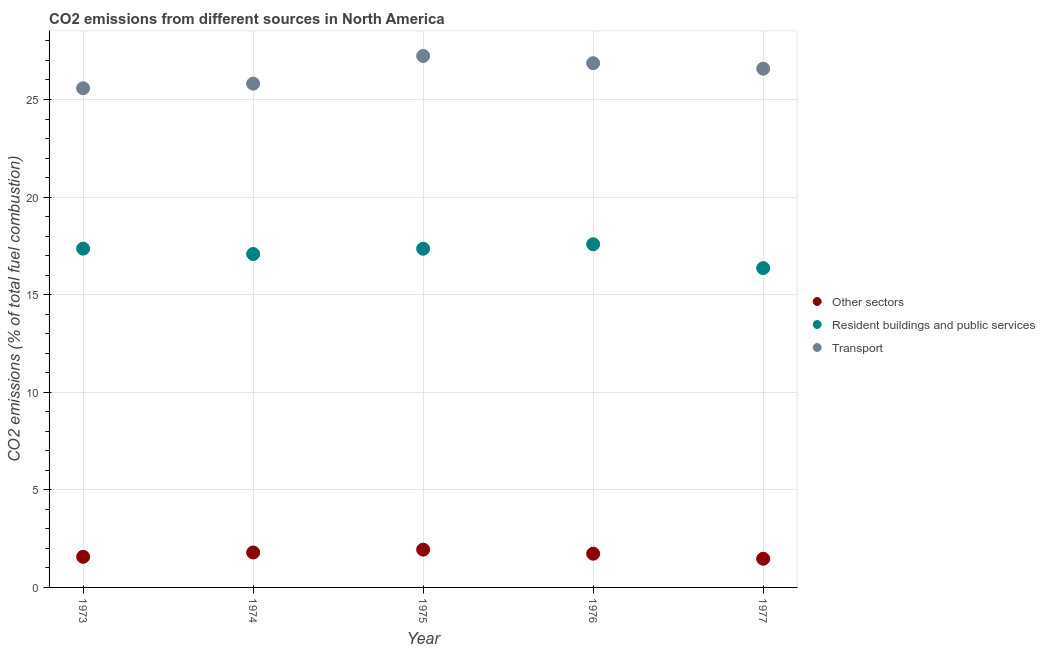How many different coloured dotlines are there?
Give a very brief answer. 3. What is the percentage of co2 emissions from resident buildings and public services in 1974?
Keep it short and to the point. 17.08. Across all years, what is the maximum percentage of co2 emissions from other sectors?
Keep it short and to the point. 1.94. Across all years, what is the minimum percentage of co2 emissions from other sectors?
Provide a short and direct response. 1.47. In which year was the percentage of co2 emissions from other sectors maximum?
Keep it short and to the point. 1975. What is the total percentage of co2 emissions from resident buildings and public services in the graph?
Offer a terse response. 85.74. What is the difference between the percentage of co2 emissions from resident buildings and public services in 1973 and that in 1975?
Keep it short and to the point. 0.01. What is the difference between the percentage of co2 emissions from resident buildings and public services in 1977 and the percentage of co2 emissions from other sectors in 1973?
Ensure brevity in your answer.  14.79. What is the average percentage of co2 emissions from other sectors per year?
Provide a short and direct response. 1.7. In the year 1976, what is the difference between the percentage of co2 emissions from other sectors and percentage of co2 emissions from resident buildings and public services?
Make the answer very short. -15.86. In how many years, is the percentage of co2 emissions from other sectors greater than 21 %?
Ensure brevity in your answer.  0. What is the ratio of the percentage of co2 emissions from transport in 1973 to that in 1975?
Keep it short and to the point. 0.94. Is the difference between the percentage of co2 emissions from resident buildings and public services in 1975 and 1976 greater than the difference between the percentage of co2 emissions from other sectors in 1975 and 1976?
Offer a very short reply. No. What is the difference between the highest and the second highest percentage of co2 emissions from resident buildings and public services?
Offer a very short reply. 0.22. What is the difference between the highest and the lowest percentage of co2 emissions from resident buildings and public services?
Ensure brevity in your answer.  1.22. In how many years, is the percentage of co2 emissions from transport greater than the average percentage of co2 emissions from transport taken over all years?
Offer a very short reply. 3. Is it the case that in every year, the sum of the percentage of co2 emissions from other sectors and percentage of co2 emissions from resident buildings and public services is greater than the percentage of co2 emissions from transport?
Your response must be concise. No. Does the percentage of co2 emissions from resident buildings and public services monotonically increase over the years?
Your response must be concise. No. Is the percentage of co2 emissions from other sectors strictly greater than the percentage of co2 emissions from transport over the years?
Give a very brief answer. No. How many years are there in the graph?
Ensure brevity in your answer.  5. What is the difference between two consecutive major ticks on the Y-axis?
Your answer should be compact. 5. Where does the legend appear in the graph?
Provide a succinct answer. Center right. How many legend labels are there?
Offer a very short reply. 3. What is the title of the graph?
Make the answer very short. CO2 emissions from different sources in North America. Does "Ireland" appear as one of the legend labels in the graph?
Make the answer very short. No. What is the label or title of the X-axis?
Provide a succinct answer. Year. What is the label or title of the Y-axis?
Provide a succinct answer. CO2 emissions (% of total fuel combustion). What is the CO2 emissions (% of total fuel combustion) of Other sectors in 1973?
Offer a terse response. 1.57. What is the CO2 emissions (% of total fuel combustion) in Resident buildings and public services in 1973?
Your response must be concise. 17.36. What is the CO2 emissions (% of total fuel combustion) in Transport in 1973?
Provide a succinct answer. 25.58. What is the CO2 emissions (% of total fuel combustion) of Other sectors in 1974?
Your response must be concise. 1.79. What is the CO2 emissions (% of total fuel combustion) in Resident buildings and public services in 1974?
Make the answer very short. 17.08. What is the CO2 emissions (% of total fuel combustion) in Transport in 1974?
Make the answer very short. 25.81. What is the CO2 emissions (% of total fuel combustion) of Other sectors in 1975?
Offer a terse response. 1.94. What is the CO2 emissions (% of total fuel combustion) of Resident buildings and public services in 1975?
Provide a succinct answer. 17.35. What is the CO2 emissions (% of total fuel combustion) in Transport in 1975?
Ensure brevity in your answer.  27.23. What is the CO2 emissions (% of total fuel combustion) of Other sectors in 1976?
Make the answer very short. 1.73. What is the CO2 emissions (% of total fuel combustion) in Resident buildings and public services in 1976?
Provide a short and direct response. 17.58. What is the CO2 emissions (% of total fuel combustion) of Transport in 1976?
Give a very brief answer. 26.86. What is the CO2 emissions (% of total fuel combustion) in Other sectors in 1977?
Your answer should be very brief. 1.47. What is the CO2 emissions (% of total fuel combustion) in Resident buildings and public services in 1977?
Keep it short and to the point. 16.36. What is the CO2 emissions (% of total fuel combustion) in Transport in 1977?
Your answer should be very brief. 26.58. Across all years, what is the maximum CO2 emissions (% of total fuel combustion) of Other sectors?
Give a very brief answer. 1.94. Across all years, what is the maximum CO2 emissions (% of total fuel combustion) in Resident buildings and public services?
Ensure brevity in your answer.  17.58. Across all years, what is the maximum CO2 emissions (% of total fuel combustion) in Transport?
Keep it short and to the point. 27.23. Across all years, what is the minimum CO2 emissions (% of total fuel combustion) in Other sectors?
Your answer should be compact. 1.47. Across all years, what is the minimum CO2 emissions (% of total fuel combustion) of Resident buildings and public services?
Offer a terse response. 16.36. Across all years, what is the minimum CO2 emissions (% of total fuel combustion) of Transport?
Make the answer very short. 25.58. What is the total CO2 emissions (% of total fuel combustion) in Other sectors in the graph?
Offer a very short reply. 8.49. What is the total CO2 emissions (% of total fuel combustion) in Resident buildings and public services in the graph?
Provide a succinct answer. 85.74. What is the total CO2 emissions (% of total fuel combustion) of Transport in the graph?
Your answer should be compact. 132.06. What is the difference between the CO2 emissions (% of total fuel combustion) in Other sectors in 1973 and that in 1974?
Offer a very short reply. -0.22. What is the difference between the CO2 emissions (% of total fuel combustion) in Resident buildings and public services in 1973 and that in 1974?
Offer a terse response. 0.28. What is the difference between the CO2 emissions (% of total fuel combustion) of Transport in 1973 and that in 1974?
Offer a very short reply. -0.24. What is the difference between the CO2 emissions (% of total fuel combustion) of Other sectors in 1973 and that in 1975?
Provide a succinct answer. -0.37. What is the difference between the CO2 emissions (% of total fuel combustion) in Resident buildings and public services in 1973 and that in 1975?
Make the answer very short. 0.01. What is the difference between the CO2 emissions (% of total fuel combustion) of Transport in 1973 and that in 1975?
Give a very brief answer. -1.66. What is the difference between the CO2 emissions (% of total fuel combustion) of Other sectors in 1973 and that in 1976?
Make the answer very short. -0.16. What is the difference between the CO2 emissions (% of total fuel combustion) in Resident buildings and public services in 1973 and that in 1976?
Your answer should be compact. -0.22. What is the difference between the CO2 emissions (% of total fuel combustion) in Transport in 1973 and that in 1976?
Offer a very short reply. -1.29. What is the difference between the CO2 emissions (% of total fuel combustion) of Other sectors in 1973 and that in 1977?
Provide a succinct answer. 0.1. What is the difference between the CO2 emissions (% of total fuel combustion) of Resident buildings and public services in 1973 and that in 1977?
Your answer should be compact. 1. What is the difference between the CO2 emissions (% of total fuel combustion) of Transport in 1973 and that in 1977?
Ensure brevity in your answer.  -1. What is the difference between the CO2 emissions (% of total fuel combustion) of Other sectors in 1974 and that in 1975?
Ensure brevity in your answer.  -0.15. What is the difference between the CO2 emissions (% of total fuel combustion) of Resident buildings and public services in 1974 and that in 1975?
Keep it short and to the point. -0.27. What is the difference between the CO2 emissions (% of total fuel combustion) in Transport in 1974 and that in 1975?
Your answer should be compact. -1.42. What is the difference between the CO2 emissions (% of total fuel combustion) in Other sectors in 1974 and that in 1976?
Provide a short and direct response. 0.06. What is the difference between the CO2 emissions (% of total fuel combustion) in Resident buildings and public services in 1974 and that in 1976?
Provide a succinct answer. -0.5. What is the difference between the CO2 emissions (% of total fuel combustion) in Transport in 1974 and that in 1976?
Offer a very short reply. -1.05. What is the difference between the CO2 emissions (% of total fuel combustion) of Other sectors in 1974 and that in 1977?
Your answer should be compact. 0.32. What is the difference between the CO2 emissions (% of total fuel combustion) of Resident buildings and public services in 1974 and that in 1977?
Offer a very short reply. 0.72. What is the difference between the CO2 emissions (% of total fuel combustion) in Transport in 1974 and that in 1977?
Offer a terse response. -0.77. What is the difference between the CO2 emissions (% of total fuel combustion) in Other sectors in 1975 and that in 1976?
Make the answer very short. 0.21. What is the difference between the CO2 emissions (% of total fuel combustion) in Resident buildings and public services in 1975 and that in 1976?
Provide a succinct answer. -0.23. What is the difference between the CO2 emissions (% of total fuel combustion) in Transport in 1975 and that in 1976?
Keep it short and to the point. 0.37. What is the difference between the CO2 emissions (% of total fuel combustion) of Other sectors in 1975 and that in 1977?
Ensure brevity in your answer.  0.47. What is the difference between the CO2 emissions (% of total fuel combustion) of Transport in 1975 and that in 1977?
Make the answer very short. 0.65. What is the difference between the CO2 emissions (% of total fuel combustion) of Other sectors in 1976 and that in 1977?
Make the answer very short. 0.26. What is the difference between the CO2 emissions (% of total fuel combustion) in Resident buildings and public services in 1976 and that in 1977?
Provide a succinct answer. 1.22. What is the difference between the CO2 emissions (% of total fuel combustion) in Transport in 1976 and that in 1977?
Your answer should be very brief. 0.28. What is the difference between the CO2 emissions (% of total fuel combustion) of Other sectors in 1973 and the CO2 emissions (% of total fuel combustion) of Resident buildings and public services in 1974?
Give a very brief answer. -15.51. What is the difference between the CO2 emissions (% of total fuel combustion) in Other sectors in 1973 and the CO2 emissions (% of total fuel combustion) in Transport in 1974?
Provide a succinct answer. -24.24. What is the difference between the CO2 emissions (% of total fuel combustion) of Resident buildings and public services in 1973 and the CO2 emissions (% of total fuel combustion) of Transport in 1974?
Your answer should be compact. -8.45. What is the difference between the CO2 emissions (% of total fuel combustion) in Other sectors in 1973 and the CO2 emissions (% of total fuel combustion) in Resident buildings and public services in 1975?
Ensure brevity in your answer.  -15.78. What is the difference between the CO2 emissions (% of total fuel combustion) of Other sectors in 1973 and the CO2 emissions (% of total fuel combustion) of Transport in 1975?
Give a very brief answer. -25.66. What is the difference between the CO2 emissions (% of total fuel combustion) of Resident buildings and public services in 1973 and the CO2 emissions (% of total fuel combustion) of Transport in 1975?
Your answer should be compact. -9.87. What is the difference between the CO2 emissions (% of total fuel combustion) of Other sectors in 1973 and the CO2 emissions (% of total fuel combustion) of Resident buildings and public services in 1976?
Your answer should be very brief. -16.01. What is the difference between the CO2 emissions (% of total fuel combustion) in Other sectors in 1973 and the CO2 emissions (% of total fuel combustion) in Transport in 1976?
Give a very brief answer. -25.29. What is the difference between the CO2 emissions (% of total fuel combustion) of Resident buildings and public services in 1973 and the CO2 emissions (% of total fuel combustion) of Transport in 1976?
Provide a succinct answer. -9.5. What is the difference between the CO2 emissions (% of total fuel combustion) of Other sectors in 1973 and the CO2 emissions (% of total fuel combustion) of Resident buildings and public services in 1977?
Ensure brevity in your answer.  -14.79. What is the difference between the CO2 emissions (% of total fuel combustion) in Other sectors in 1973 and the CO2 emissions (% of total fuel combustion) in Transport in 1977?
Give a very brief answer. -25.01. What is the difference between the CO2 emissions (% of total fuel combustion) in Resident buildings and public services in 1973 and the CO2 emissions (% of total fuel combustion) in Transport in 1977?
Provide a short and direct response. -9.22. What is the difference between the CO2 emissions (% of total fuel combustion) of Other sectors in 1974 and the CO2 emissions (% of total fuel combustion) of Resident buildings and public services in 1975?
Your answer should be very brief. -15.56. What is the difference between the CO2 emissions (% of total fuel combustion) of Other sectors in 1974 and the CO2 emissions (% of total fuel combustion) of Transport in 1975?
Your response must be concise. -25.44. What is the difference between the CO2 emissions (% of total fuel combustion) of Resident buildings and public services in 1974 and the CO2 emissions (% of total fuel combustion) of Transport in 1975?
Your answer should be very brief. -10.15. What is the difference between the CO2 emissions (% of total fuel combustion) in Other sectors in 1974 and the CO2 emissions (% of total fuel combustion) in Resident buildings and public services in 1976?
Keep it short and to the point. -15.79. What is the difference between the CO2 emissions (% of total fuel combustion) in Other sectors in 1974 and the CO2 emissions (% of total fuel combustion) in Transport in 1976?
Give a very brief answer. -25.07. What is the difference between the CO2 emissions (% of total fuel combustion) of Resident buildings and public services in 1974 and the CO2 emissions (% of total fuel combustion) of Transport in 1976?
Your answer should be compact. -9.78. What is the difference between the CO2 emissions (% of total fuel combustion) of Other sectors in 1974 and the CO2 emissions (% of total fuel combustion) of Resident buildings and public services in 1977?
Ensure brevity in your answer.  -14.57. What is the difference between the CO2 emissions (% of total fuel combustion) of Other sectors in 1974 and the CO2 emissions (% of total fuel combustion) of Transport in 1977?
Make the answer very short. -24.79. What is the difference between the CO2 emissions (% of total fuel combustion) of Resident buildings and public services in 1974 and the CO2 emissions (% of total fuel combustion) of Transport in 1977?
Your answer should be compact. -9.5. What is the difference between the CO2 emissions (% of total fuel combustion) of Other sectors in 1975 and the CO2 emissions (% of total fuel combustion) of Resident buildings and public services in 1976?
Your answer should be very brief. -15.65. What is the difference between the CO2 emissions (% of total fuel combustion) in Other sectors in 1975 and the CO2 emissions (% of total fuel combustion) in Transport in 1976?
Your response must be concise. -24.93. What is the difference between the CO2 emissions (% of total fuel combustion) in Resident buildings and public services in 1975 and the CO2 emissions (% of total fuel combustion) in Transport in 1976?
Your answer should be compact. -9.51. What is the difference between the CO2 emissions (% of total fuel combustion) in Other sectors in 1975 and the CO2 emissions (% of total fuel combustion) in Resident buildings and public services in 1977?
Make the answer very short. -14.42. What is the difference between the CO2 emissions (% of total fuel combustion) of Other sectors in 1975 and the CO2 emissions (% of total fuel combustion) of Transport in 1977?
Your answer should be very brief. -24.64. What is the difference between the CO2 emissions (% of total fuel combustion) in Resident buildings and public services in 1975 and the CO2 emissions (% of total fuel combustion) in Transport in 1977?
Your answer should be compact. -9.23. What is the difference between the CO2 emissions (% of total fuel combustion) in Other sectors in 1976 and the CO2 emissions (% of total fuel combustion) in Resident buildings and public services in 1977?
Provide a succinct answer. -14.63. What is the difference between the CO2 emissions (% of total fuel combustion) of Other sectors in 1976 and the CO2 emissions (% of total fuel combustion) of Transport in 1977?
Offer a very short reply. -24.85. What is the difference between the CO2 emissions (% of total fuel combustion) in Resident buildings and public services in 1976 and the CO2 emissions (% of total fuel combustion) in Transport in 1977?
Keep it short and to the point. -9. What is the average CO2 emissions (% of total fuel combustion) in Other sectors per year?
Your answer should be very brief. 1.7. What is the average CO2 emissions (% of total fuel combustion) in Resident buildings and public services per year?
Offer a very short reply. 17.15. What is the average CO2 emissions (% of total fuel combustion) of Transport per year?
Keep it short and to the point. 26.41. In the year 1973, what is the difference between the CO2 emissions (% of total fuel combustion) in Other sectors and CO2 emissions (% of total fuel combustion) in Resident buildings and public services?
Your response must be concise. -15.79. In the year 1973, what is the difference between the CO2 emissions (% of total fuel combustion) in Other sectors and CO2 emissions (% of total fuel combustion) in Transport?
Ensure brevity in your answer.  -24.01. In the year 1973, what is the difference between the CO2 emissions (% of total fuel combustion) in Resident buildings and public services and CO2 emissions (% of total fuel combustion) in Transport?
Keep it short and to the point. -8.22. In the year 1974, what is the difference between the CO2 emissions (% of total fuel combustion) in Other sectors and CO2 emissions (% of total fuel combustion) in Resident buildings and public services?
Your response must be concise. -15.29. In the year 1974, what is the difference between the CO2 emissions (% of total fuel combustion) of Other sectors and CO2 emissions (% of total fuel combustion) of Transport?
Make the answer very short. -24.02. In the year 1974, what is the difference between the CO2 emissions (% of total fuel combustion) in Resident buildings and public services and CO2 emissions (% of total fuel combustion) in Transport?
Your answer should be compact. -8.73. In the year 1975, what is the difference between the CO2 emissions (% of total fuel combustion) in Other sectors and CO2 emissions (% of total fuel combustion) in Resident buildings and public services?
Make the answer very short. -15.42. In the year 1975, what is the difference between the CO2 emissions (% of total fuel combustion) in Other sectors and CO2 emissions (% of total fuel combustion) in Transport?
Your response must be concise. -25.29. In the year 1975, what is the difference between the CO2 emissions (% of total fuel combustion) of Resident buildings and public services and CO2 emissions (% of total fuel combustion) of Transport?
Make the answer very short. -9.88. In the year 1976, what is the difference between the CO2 emissions (% of total fuel combustion) of Other sectors and CO2 emissions (% of total fuel combustion) of Resident buildings and public services?
Keep it short and to the point. -15.86. In the year 1976, what is the difference between the CO2 emissions (% of total fuel combustion) in Other sectors and CO2 emissions (% of total fuel combustion) in Transport?
Offer a very short reply. -25.13. In the year 1976, what is the difference between the CO2 emissions (% of total fuel combustion) of Resident buildings and public services and CO2 emissions (% of total fuel combustion) of Transport?
Make the answer very short. -9.28. In the year 1977, what is the difference between the CO2 emissions (% of total fuel combustion) of Other sectors and CO2 emissions (% of total fuel combustion) of Resident buildings and public services?
Give a very brief answer. -14.89. In the year 1977, what is the difference between the CO2 emissions (% of total fuel combustion) of Other sectors and CO2 emissions (% of total fuel combustion) of Transport?
Provide a succinct answer. -25.11. In the year 1977, what is the difference between the CO2 emissions (% of total fuel combustion) of Resident buildings and public services and CO2 emissions (% of total fuel combustion) of Transport?
Offer a very short reply. -10.22. What is the ratio of the CO2 emissions (% of total fuel combustion) in Other sectors in 1973 to that in 1974?
Your answer should be compact. 0.88. What is the ratio of the CO2 emissions (% of total fuel combustion) in Resident buildings and public services in 1973 to that in 1974?
Make the answer very short. 1.02. What is the ratio of the CO2 emissions (% of total fuel combustion) in Transport in 1973 to that in 1974?
Offer a terse response. 0.99. What is the ratio of the CO2 emissions (% of total fuel combustion) of Other sectors in 1973 to that in 1975?
Your answer should be compact. 0.81. What is the ratio of the CO2 emissions (% of total fuel combustion) in Resident buildings and public services in 1973 to that in 1975?
Ensure brevity in your answer.  1. What is the ratio of the CO2 emissions (% of total fuel combustion) of Transport in 1973 to that in 1975?
Keep it short and to the point. 0.94. What is the ratio of the CO2 emissions (% of total fuel combustion) in Other sectors in 1973 to that in 1976?
Offer a terse response. 0.91. What is the ratio of the CO2 emissions (% of total fuel combustion) in Resident buildings and public services in 1973 to that in 1976?
Your answer should be compact. 0.99. What is the ratio of the CO2 emissions (% of total fuel combustion) of Transport in 1973 to that in 1976?
Your answer should be very brief. 0.95. What is the ratio of the CO2 emissions (% of total fuel combustion) in Other sectors in 1973 to that in 1977?
Provide a short and direct response. 1.07. What is the ratio of the CO2 emissions (% of total fuel combustion) in Resident buildings and public services in 1973 to that in 1977?
Make the answer very short. 1.06. What is the ratio of the CO2 emissions (% of total fuel combustion) of Transport in 1973 to that in 1977?
Provide a short and direct response. 0.96. What is the ratio of the CO2 emissions (% of total fuel combustion) in Other sectors in 1974 to that in 1975?
Provide a succinct answer. 0.92. What is the ratio of the CO2 emissions (% of total fuel combustion) of Resident buildings and public services in 1974 to that in 1975?
Your response must be concise. 0.98. What is the ratio of the CO2 emissions (% of total fuel combustion) of Transport in 1974 to that in 1975?
Your response must be concise. 0.95. What is the ratio of the CO2 emissions (% of total fuel combustion) of Other sectors in 1974 to that in 1976?
Provide a succinct answer. 1.04. What is the ratio of the CO2 emissions (% of total fuel combustion) of Resident buildings and public services in 1974 to that in 1976?
Keep it short and to the point. 0.97. What is the ratio of the CO2 emissions (% of total fuel combustion) of Other sectors in 1974 to that in 1977?
Provide a succinct answer. 1.22. What is the ratio of the CO2 emissions (% of total fuel combustion) of Resident buildings and public services in 1974 to that in 1977?
Provide a short and direct response. 1.04. What is the ratio of the CO2 emissions (% of total fuel combustion) in Transport in 1974 to that in 1977?
Offer a terse response. 0.97. What is the ratio of the CO2 emissions (% of total fuel combustion) in Other sectors in 1975 to that in 1976?
Make the answer very short. 1.12. What is the ratio of the CO2 emissions (% of total fuel combustion) in Resident buildings and public services in 1975 to that in 1976?
Offer a very short reply. 0.99. What is the ratio of the CO2 emissions (% of total fuel combustion) of Transport in 1975 to that in 1976?
Make the answer very short. 1.01. What is the ratio of the CO2 emissions (% of total fuel combustion) of Other sectors in 1975 to that in 1977?
Your answer should be very brief. 1.32. What is the ratio of the CO2 emissions (% of total fuel combustion) in Resident buildings and public services in 1975 to that in 1977?
Offer a terse response. 1.06. What is the ratio of the CO2 emissions (% of total fuel combustion) in Transport in 1975 to that in 1977?
Ensure brevity in your answer.  1.02. What is the ratio of the CO2 emissions (% of total fuel combustion) of Other sectors in 1976 to that in 1977?
Your response must be concise. 1.18. What is the ratio of the CO2 emissions (% of total fuel combustion) in Resident buildings and public services in 1976 to that in 1977?
Provide a succinct answer. 1.07. What is the ratio of the CO2 emissions (% of total fuel combustion) of Transport in 1976 to that in 1977?
Offer a terse response. 1.01. What is the difference between the highest and the second highest CO2 emissions (% of total fuel combustion) of Other sectors?
Offer a terse response. 0.15. What is the difference between the highest and the second highest CO2 emissions (% of total fuel combustion) in Resident buildings and public services?
Provide a succinct answer. 0.22. What is the difference between the highest and the second highest CO2 emissions (% of total fuel combustion) in Transport?
Your response must be concise. 0.37. What is the difference between the highest and the lowest CO2 emissions (% of total fuel combustion) in Other sectors?
Keep it short and to the point. 0.47. What is the difference between the highest and the lowest CO2 emissions (% of total fuel combustion) in Resident buildings and public services?
Offer a terse response. 1.22. What is the difference between the highest and the lowest CO2 emissions (% of total fuel combustion) in Transport?
Your response must be concise. 1.66. 